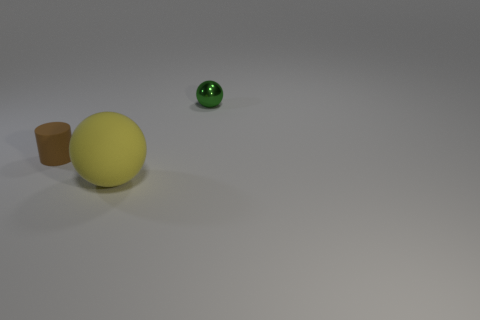There is a object right of the yellow thing; is it the same size as the brown thing?
Make the answer very short. Yes. Are there fewer big rubber balls than small cyan cylinders?
Give a very brief answer. No. The matte thing in front of the tiny object that is in front of the object that is behind the small cylinder is what shape?
Give a very brief answer. Sphere. Is there another thing that has the same material as the tiny brown thing?
Keep it short and to the point. Yes. Is the color of the small thing behind the small brown matte cylinder the same as the ball on the left side of the green metal ball?
Your answer should be compact. No. Is the number of big yellow balls that are behind the large ball less than the number of yellow metallic blocks?
Your response must be concise. No. What number of things are small green shiny things or objects that are behind the yellow ball?
Provide a short and direct response. 2. There is a cylinder that is the same material as the yellow thing; what is its color?
Give a very brief answer. Brown. What number of objects are matte balls or large purple things?
Your answer should be very brief. 1. The cylinder that is the same size as the green ball is what color?
Offer a terse response. Brown. 